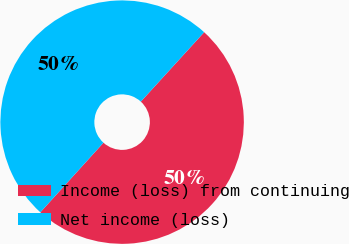Convert chart. <chart><loc_0><loc_0><loc_500><loc_500><pie_chart><fcel>Income (loss) from continuing<fcel>Net income (loss)<nl><fcel>49.95%<fcel>50.05%<nl></chart> 